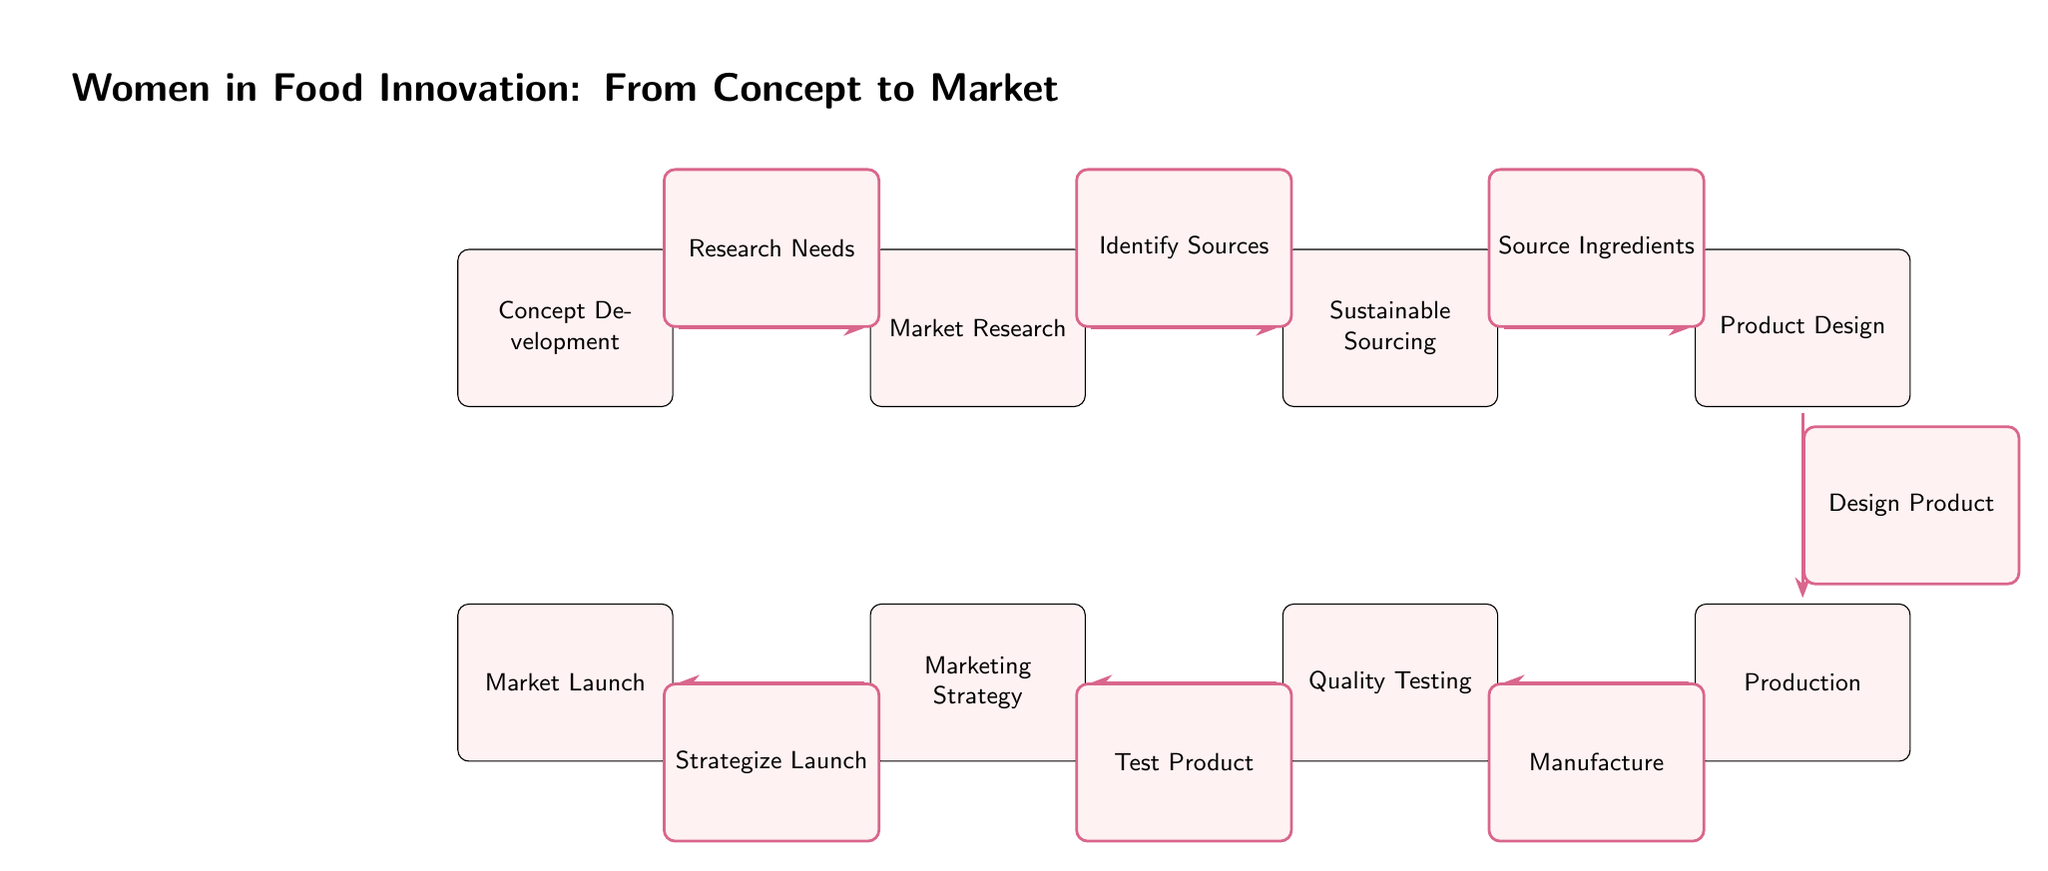What is the first step in the food innovation process according to the diagram? The diagram shows "Concept Development" as the first node in the food innovation process, indicating that it is the initial step.
Answer: Concept Development How many main nodes are present in the food innovation journey? By counting the nodes visually, there are a total of 7 main nodes presented, each representing different stages of the process.
Answer: 7 What node comes after "Market Research"? Following the flow in the diagram, the node that directly follows "Market Research" is "Sustainable Sourcing".
Answer: Sustainable Sourcing What is the role of the node "Quality Testing"? In the diagram, "Quality Testing" is positioned as a separate step that corresponds to ensuring the product meets certain standards before it moves to "Marketing Strategy".
Answer: Ensuring Quality Which two nodes are directly connected to the "Production" node? The nodes "Product Design" and "Quality Testing" are both directly connected to the "Production" node, showing their relationship in the process.
Answer: Product Design and Quality Testing What step occurs after "Design Product"? Based on the flow of the diagram, the step that follows "Design Product" is "Production", clearly indicating the sequence in the food innovation process.
Answer: Production What is the final phase in the food innovation process depicted in the diagram? The diagram illustrates "Market Launch" as the final phase in the food innovation process, indicating the culmination of all prior steps.
Answer: Market Launch What action is associated with the edge connecting "Sustainable Sourcing" and "Product Design"? The edge relationship indicates the action of "Source Ingredients" which connects these two nodes, showing that sourcing is integral to design.
Answer: Source Ingredients How do the nodes "Testing" and "Marketing Strategy" relate in the innovation process? The diagram shows that "Quality Testing" precedes "Marketing Strategy", indicating that testing is necessary before formulating a marketing strategy for the product.
Answer: Quality Testing precedes Marketing Strategy 